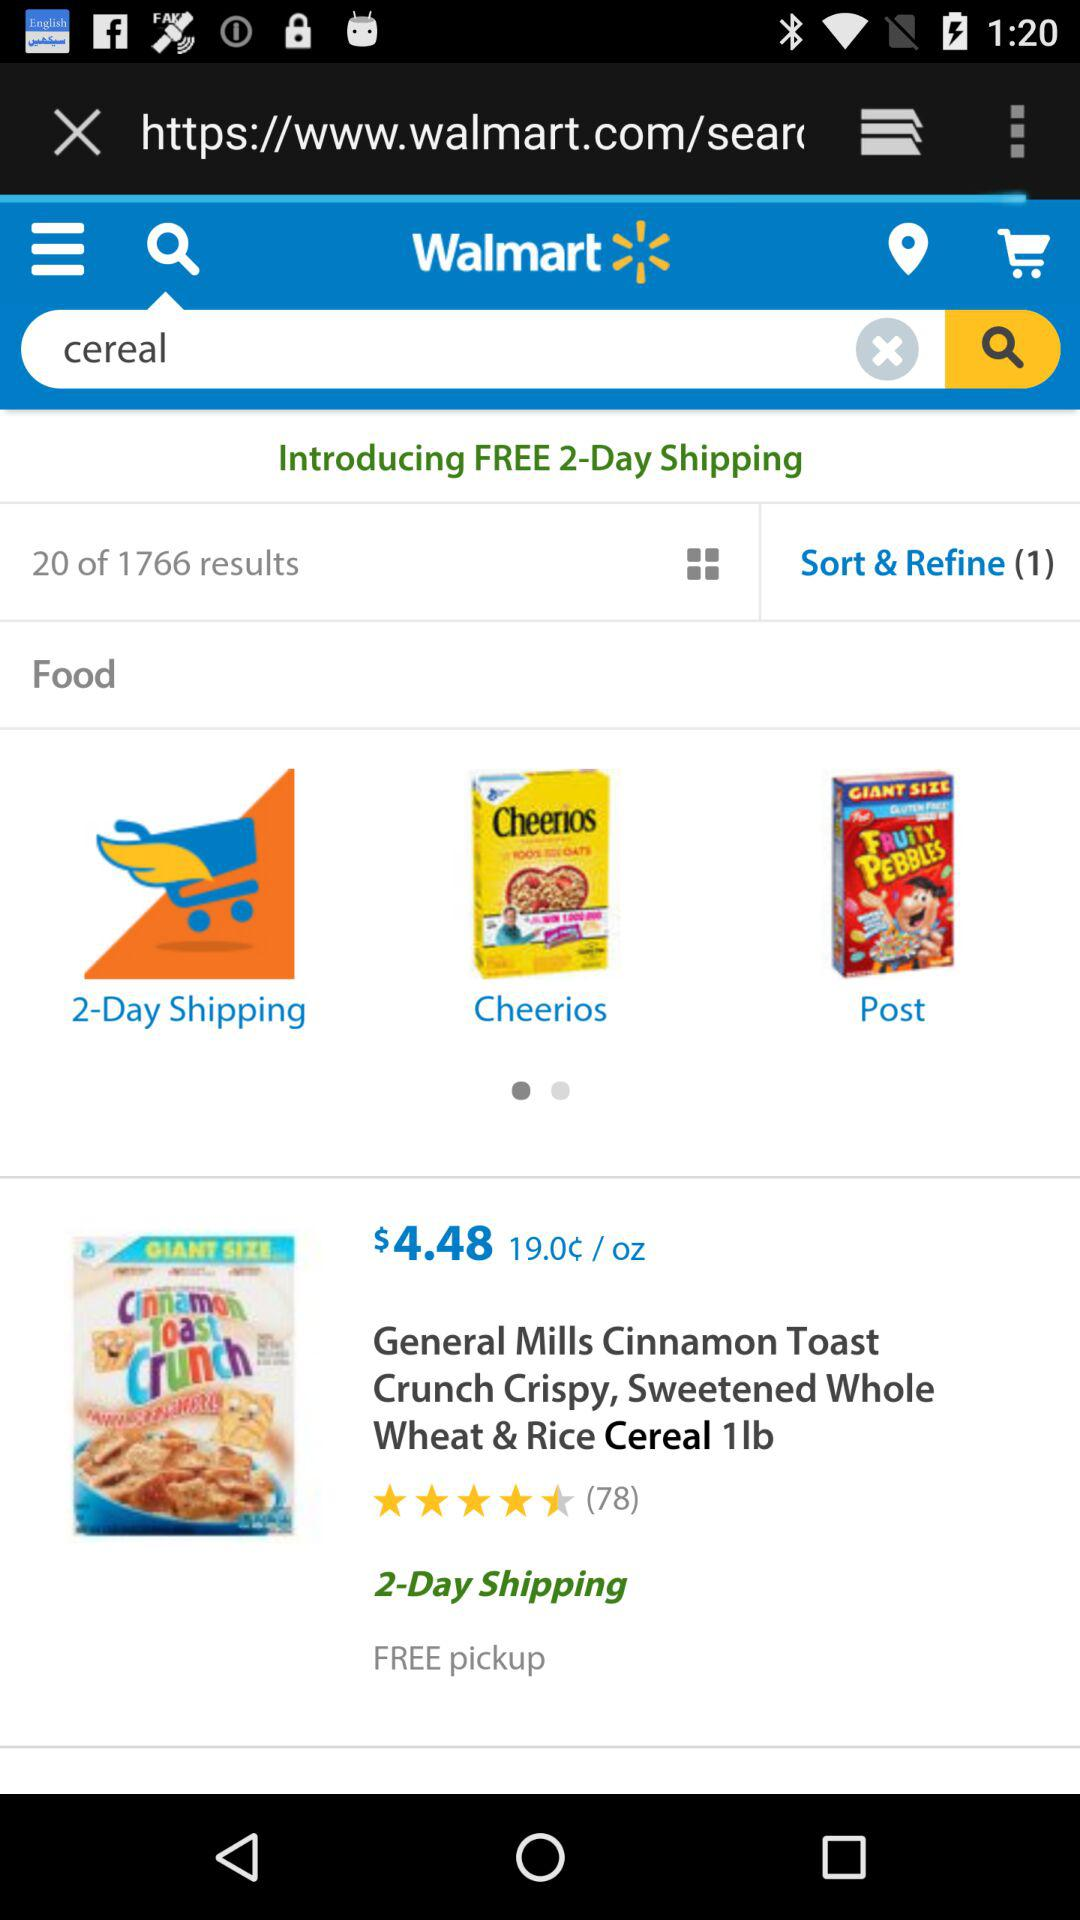How many reviews are there? There are 78 reviews. 